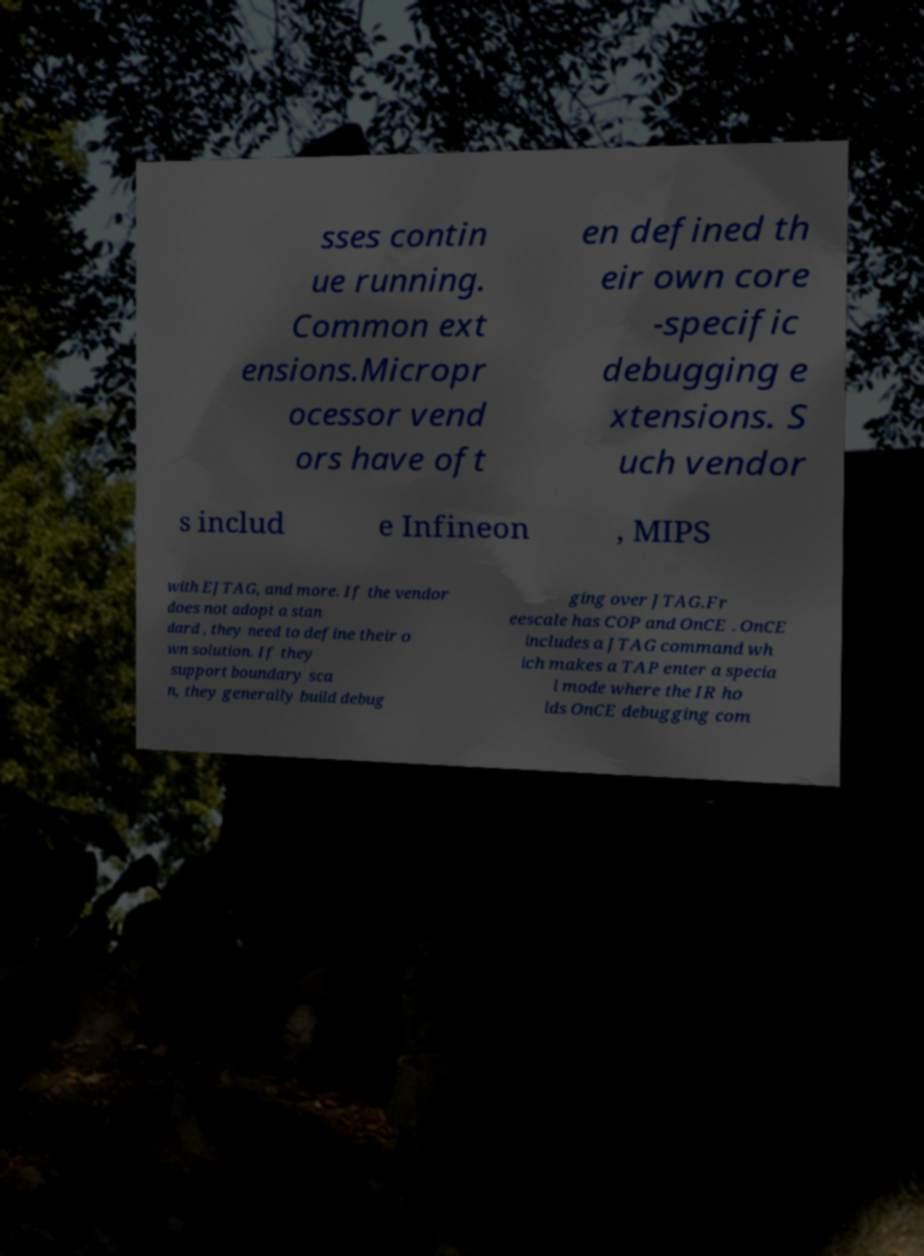Please read and relay the text visible in this image. What does it say? sses contin ue running. Common ext ensions.Micropr ocessor vend ors have oft en defined th eir own core -specific debugging e xtensions. S uch vendor s includ e Infineon , MIPS with EJTAG, and more. If the vendor does not adopt a stan dard , they need to define their o wn solution. If they support boundary sca n, they generally build debug ging over JTAG.Fr eescale has COP and OnCE . OnCE includes a JTAG command wh ich makes a TAP enter a specia l mode where the IR ho lds OnCE debugging com 